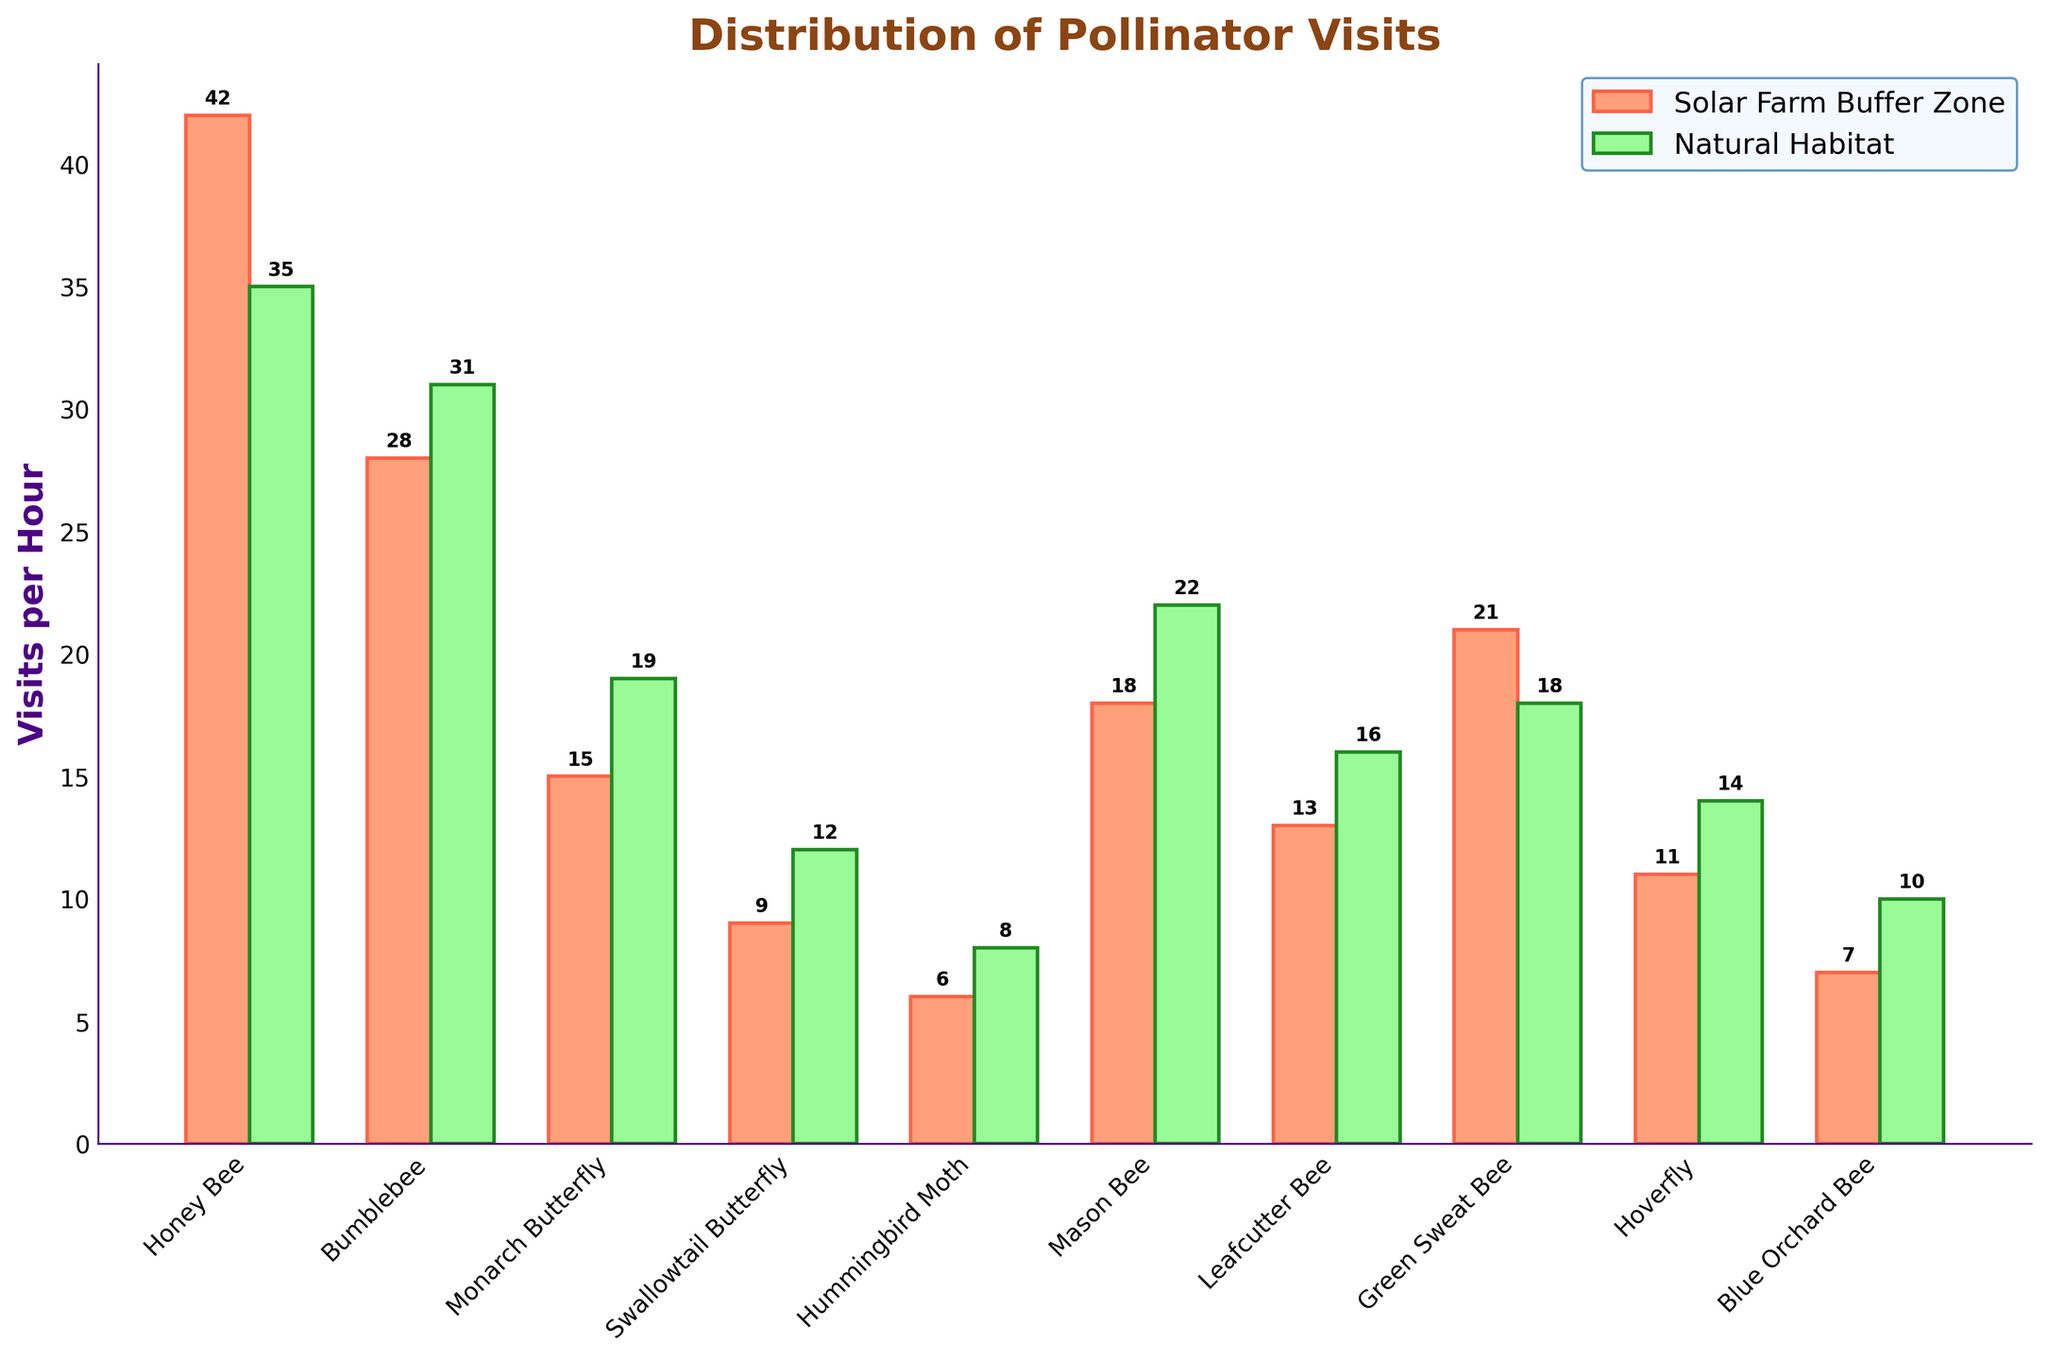what's the difference in pollinator visits for Honey Bee between Solar Farm Buffer Zone and Natural Habitat? The number of visits per hour for Honey Bee in Solar Farm Buffer Zone is 42, and in Natural Habitat is 35. The difference can be calculated as 42 - 35 = 7.
Answer: 7 Which species have higher visits in the Natural Habitat compared to the Solar Farm Buffer Zone? By comparing each species in Solar Farm Buffer Zone and Natural Habitat, we see that Bumblebee (31 vs 28), Monarch Butterfly (19 vs 15), Swallowtail Butterfly (12 vs 9), Hummingbird Moth (8 vs 6), Mason Bee (22 vs 18), Leafcutter Bee (16 vs 13), and Hoverfly (14 vs 11) have higher visits in Natural Habitat.
Answer: Bumblebee, Monarch Butterfly, Swallowtail Butterfly, Hummingbird Moth, Mason Bee, Leafcutter Bee, Hoverfly What's the total number of visits for Green Sweat Bee across both zones? The number of Green Sweat Bee visits in Solar Farm Buffer Zone is 21 and in Natural Habitat is 18. Summing these values gives 21 + 18 = 39.
Answer: 39 Which species has the lowest number of visits in the Solar Farm Buffer Zone? The species with the lowest number of visits in the Solar Farm Buffer Zone can be identified by looking at the shortest bar. The Hummingbird Moth has the lowest number of visits with 6 visits per hour.
Answer: Hummingbird Moth What is the average number of pollinator visits in the Natural Habitat? To find the average, we sum up all visits in the Natural Habitat ((35 + 31 + 19 + 12 + 8 + 22 + 16 + 18 + 14 + 10) = 185) and then divide by the number of species (10). Thus, the average is 185 / 10 = 18.5.
Answer: 18.5 Which color represents the Solar Farm Buffer Zone in the bar chart? By observing the labels and the colors of the bars, the Solar Farm Buffer Zone bars are represented by the orange-red color.
Answer: orange-red How many species have more than 20 visits per hour in the Solar Farm Buffer Zone? By inspecting the bar heights, Honey Bee (42), Bumblebee (28), Green Sweat Bee (21), and Mason Bee (18) have the highest number of visits, but only Honey Bee, Bumblebee, and Green Sweat Bee have more than 20 visits per hour.
Answer: 3 What's the total difference in visits between Solar Farm Buffer Zone and Natural Habitat for all species combined? Summing the visits in Solar Farm Buffer Zone (42 + 28 + 15 + 9 + 6 + 18 + 13 + 21 + 11 + 7 = 170) and in Natural Habitat (35 + 31 + 19 + 12 + 8 + 22 + 16 + 18 + 14 + 10 = 185), the difference is 185 - 170 = 15.
Answer: 15 Which species show equal the difference in visits between the two zones? By looking at each species' visits, only the Honey Bee has equal or higher visits in Solar Farm Buffer Zone compared to Natural Habitat, indicating no species show equal differences.
Answer: None 